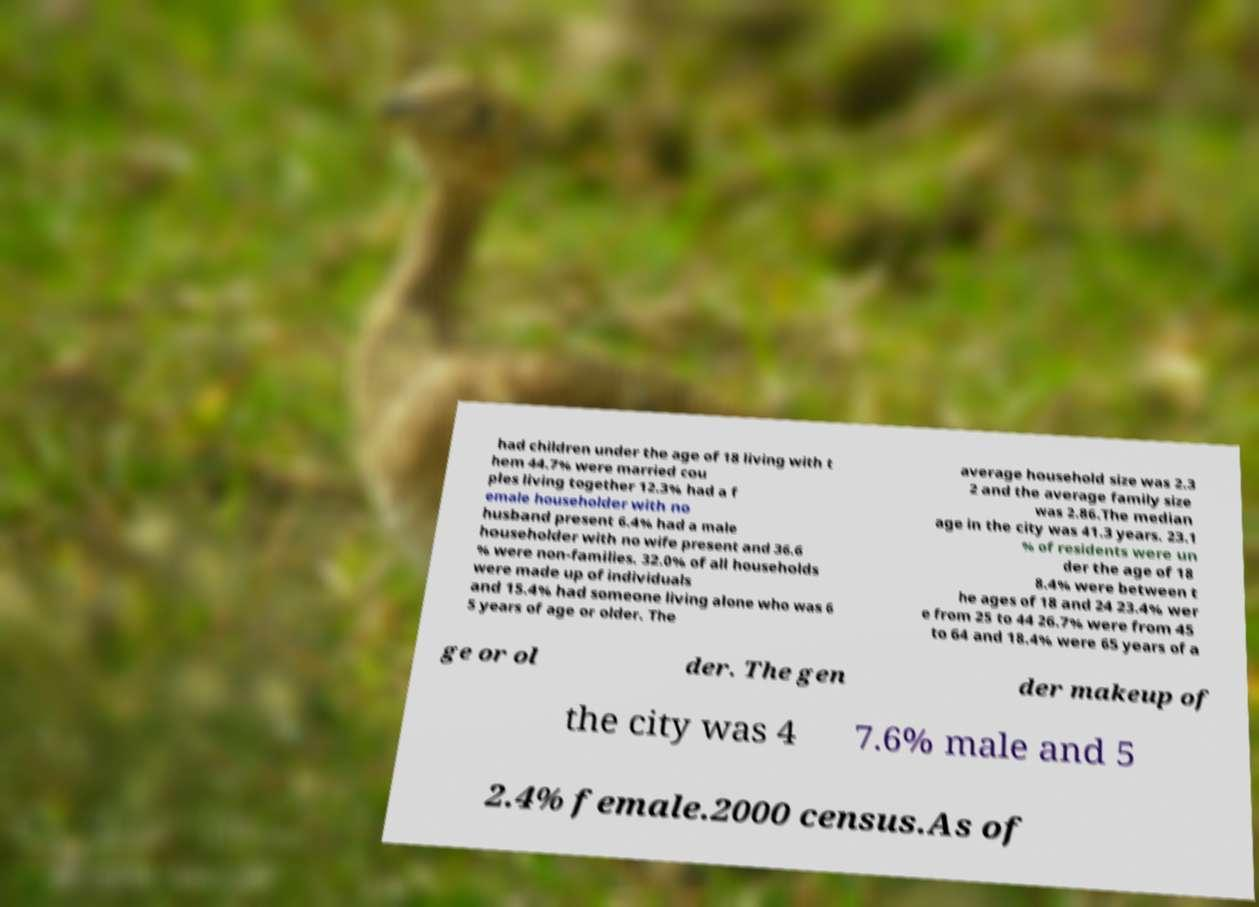Can you read and provide the text displayed in the image?This photo seems to have some interesting text. Can you extract and type it out for me? had children under the age of 18 living with t hem 44.7% were married cou ples living together 12.3% had a f emale householder with no husband present 6.4% had a male householder with no wife present and 36.6 % were non-families. 32.0% of all households were made up of individuals and 15.4% had someone living alone who was 6 5 years of age or older. The average household size was 2.3 2 and the average family size was 2.86.The median age in the city was 41.3 years. 23.1 % of residents were un der the age of 18 8.4% were between t he ages of 18 and 24 23.4% wer e from 25 to 44 26.7% were from 45 to 64 and 18.4% were 65 years of a ge or ol der. The gen der makeup of the city was 4 7.6% male and 5 2.4% female.2000 census.As of 